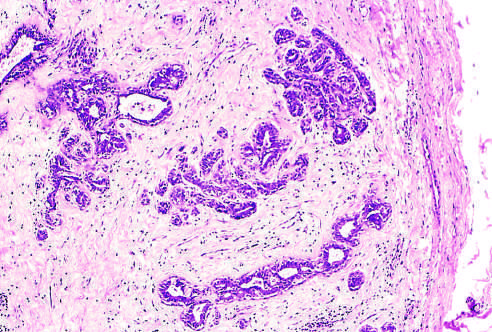what does the fibrous capsule delimit?
Answer the question using a single word or phrase. The tumor 